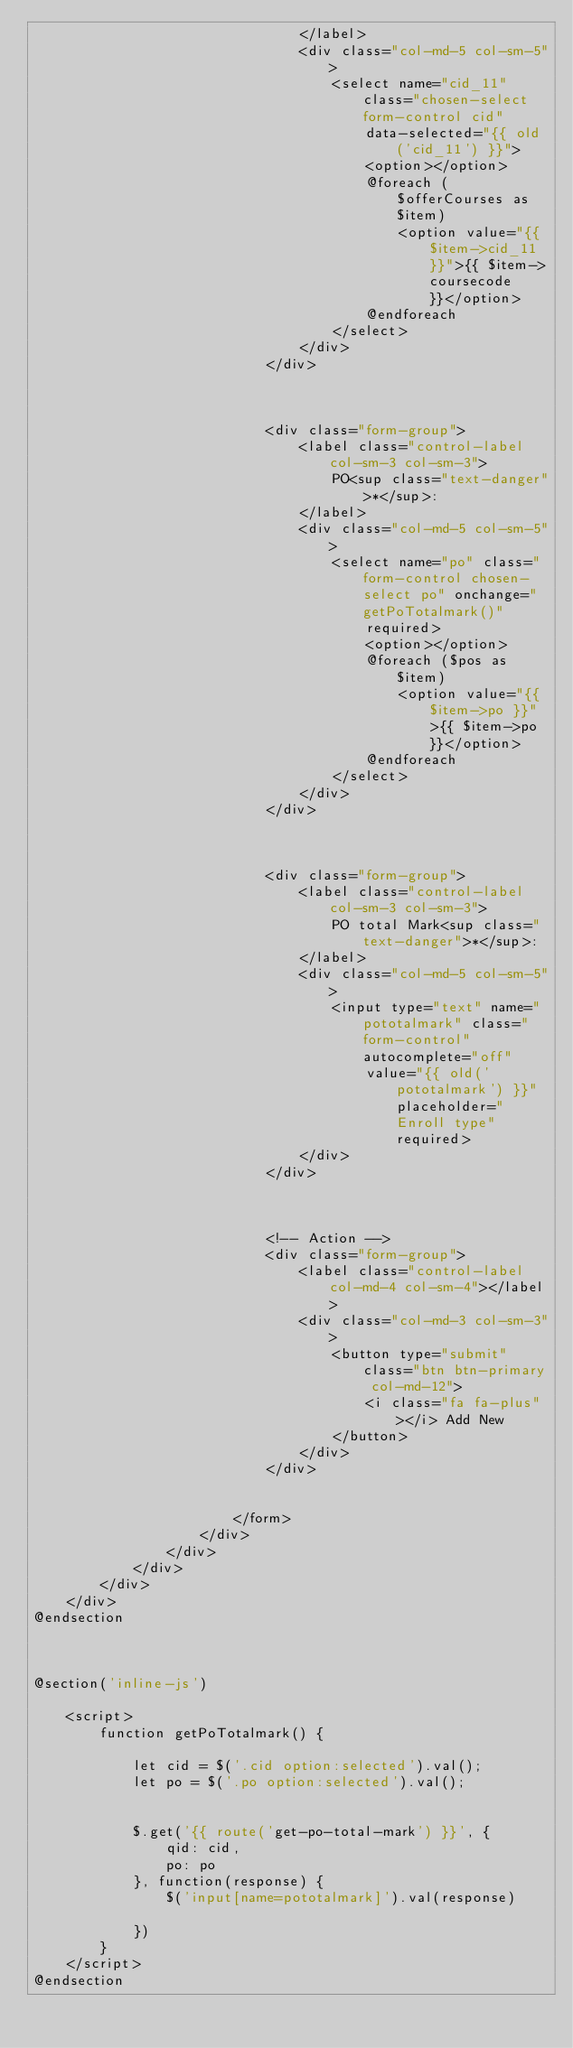Convert code to text. <code><loc_0><loc_0><loc_500><loc_500><_PHP_>                                </label>
                                <div class="col-md-5 col-sm-5">
                                    <select name="cid_11" class="chosen-select form-control cid"
                                        data-selected="{{ old('cid_11') }}">
                                        <option></option>
                                        @foreach ($offerCourses as $item)
                                            <option value="{{ $item->cid_11 }}">{{ $item->coursecode }}</option>
                                        @endforeach
                                    </select>
                                </div>
                            </div>



                            <div class="form-group">
                                <label class="control-label col-sm-3 col-sm-3">
                                    PO<sup class="text-danger">*</sup>:
                                </label>
                                <div class="col-md-5 col-sm-5">
                                    <select name="po" class="form-control chosen-select po" onchange="getPoTotalmark()"
                                        required>
                                        <option></option>
                                        @foreach ($pos as $item)
                                            <option value="{{ $item->po }}">{{ $item->po }}</option>
                                        @endforeach
                                    </select>
                                </div>
                            </div>



                            <div class="form-group">
                                <label class="control-label col-sm-3 col-sm-3">
                                    PO total Mark<sup class="text-danger">*</sup>:
                                </label>
                                <div class="col-md-5 col-sm-5">
                                    <input type="text" name="pototalmark" class="form-control" autocomplete="off"
                                        value="{{ old('pototalmark') }}" placeholder="Enroll type" required>
                                </div>
                            </div>



                            <!-- Action -->
                            <div class="form-group">
                                <label class="control-label col-md-4 col-sm-4"></label>
                                <div class="col-md-3 col-sm-3">
                                    <button type="submit" class="btn btn-primary col-md-12">
                                        <i class="fa fa-plus"></i> Add New
                                    </button>
                                </div>
                            </div>


                        </form>
                    </div>
                </div>
            </div>
        </div>
    </div>
@endsection



@section('inline-js')

    <script>
        function getPoTotalmark() {

            let cid = $('.cid option:selected').val();
            let po = $('.po option:selected').val();


            $.get('{{ route('get-po-total-mark') }}', {
                qid: cid,
                po: po
            }, function(response) {
                $('input[name=pototalmark]').val(response)

            })
        }
    </script>
@endsection
</code> 